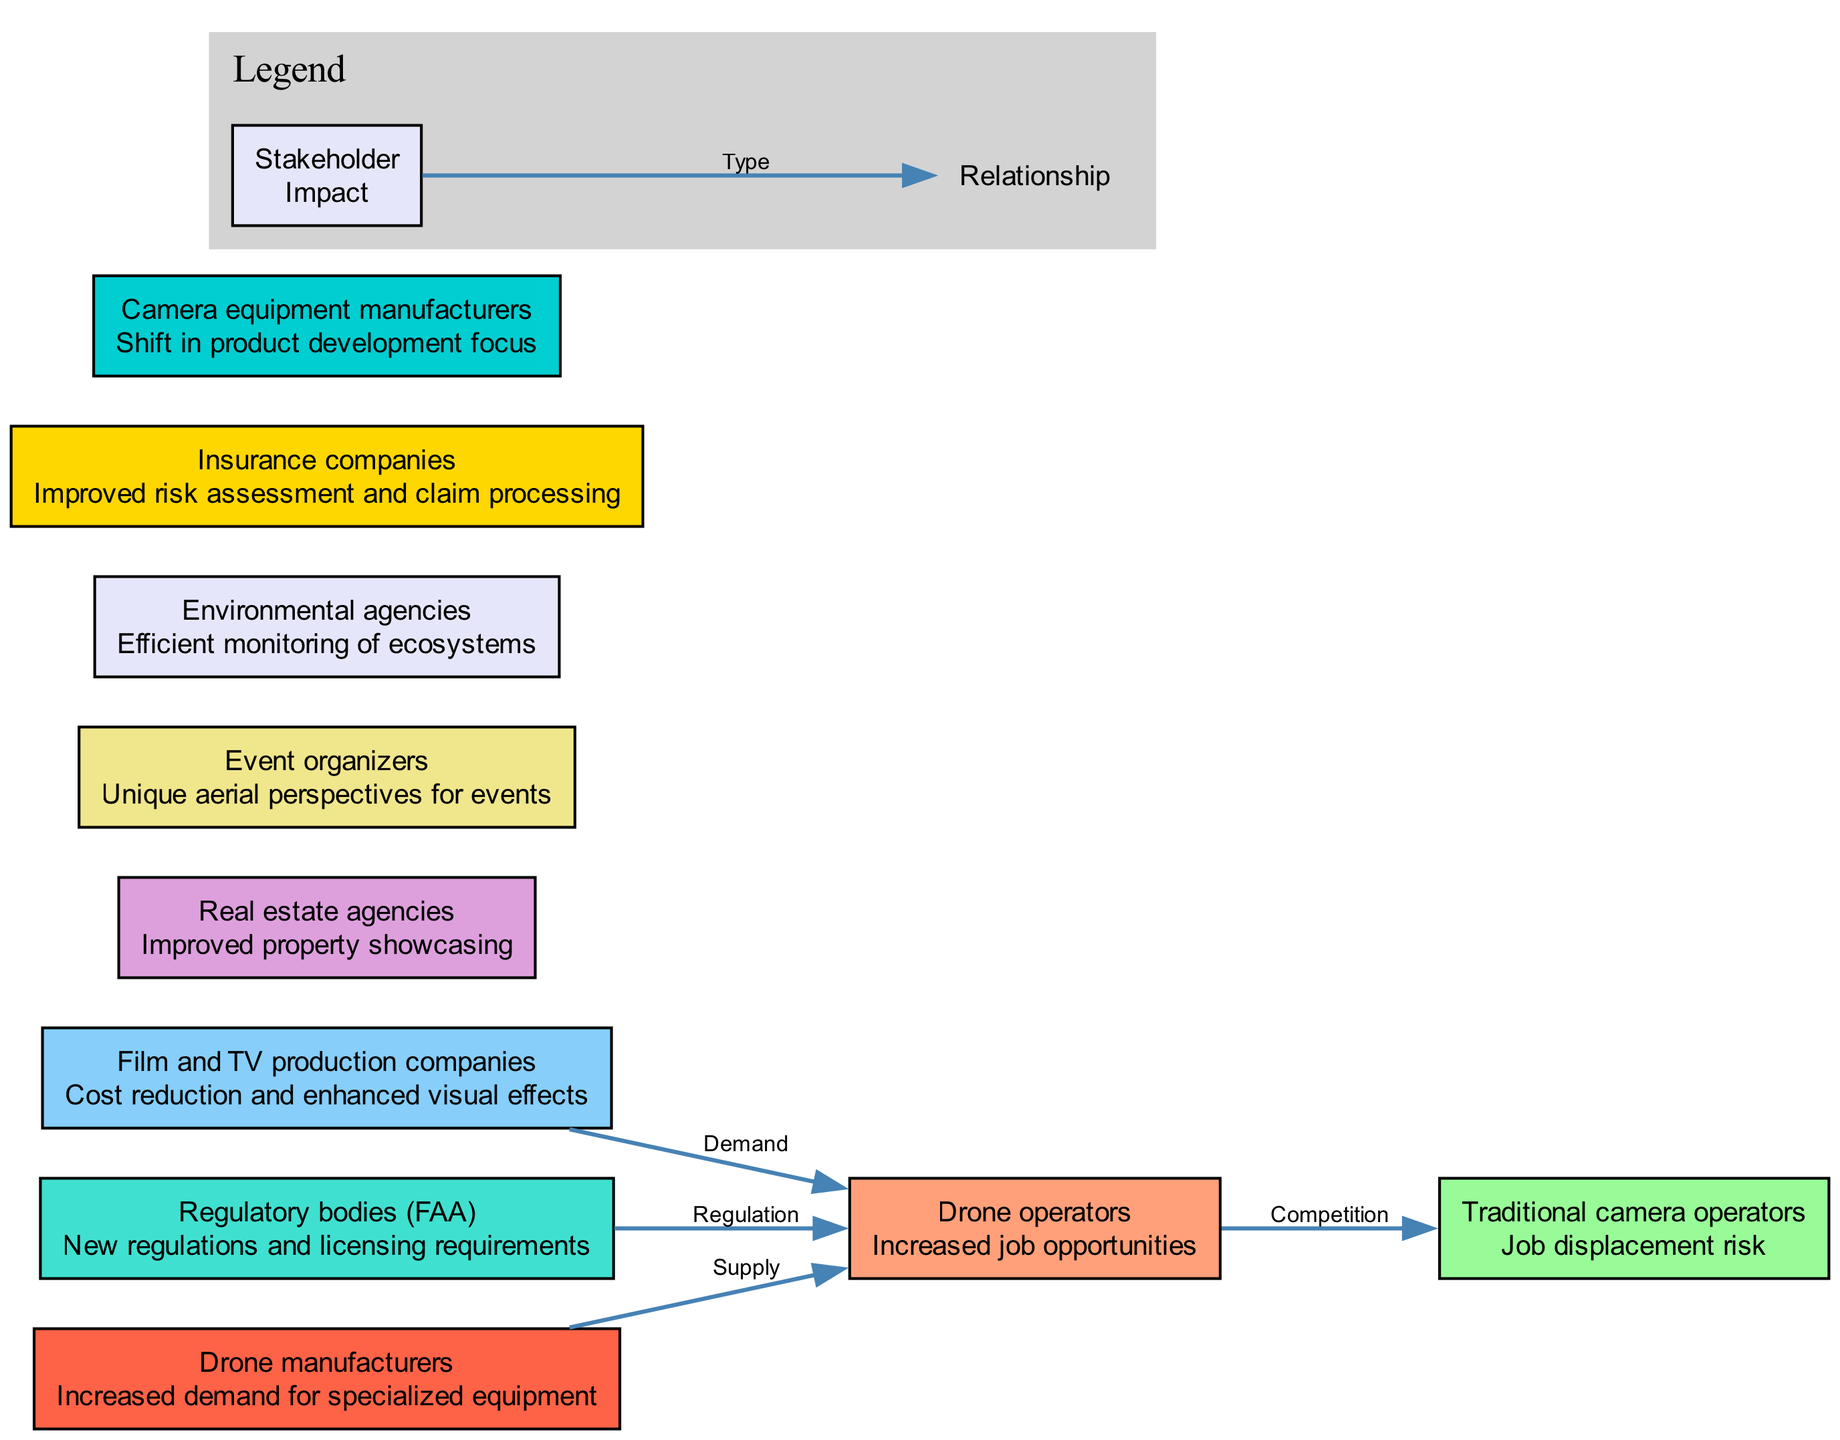What is the impact on drone operators? The diagram shows that the impact on drone operators is "Increased job opportunities," which is directly stated under their node.
Answer: Increased job opportunities How many stakeholders are represented in the diagram? By counting the nodes labeled with stakeholders in the diagram, there are a total of ten stakeholders represented.
Answer: 10 What type of relationship exists between drone operators and traditional camera operators? The diagram specifies that the relationship between drone operators and traditional camera operators is categorized as "Competition," which is indicated on the connecting edge.
Answer: Competition Which stakeholder has an impact related to ecosystem monitoring? The diagram indicates that the "Environmental agencies" stakeholder has the impact of "Efficient monitoring of ecosystems," which can be found in their designated node.
Answer: Environmental agencies What is the relationship type between regulatory bodies and drone operators? According to the diagram, the type of relationship between regulatory bodies (FAA) and drone operators is labeled as "Regulation," which is shown on the edge connecting these two nodes.
Answer: Regulation Which stakeholder is at risk of job displacement? The diagram explicitly states that "Traditional camera operators" are at risk of job displacement, as noted under their impact section in the diagram.
Answer: Traditional camera operators How does the demand for drone operators relate to film and TV production companies? The diagram shows that the relationship type is "Demand," indicating that film and TV production companies drive demand for services provided by drone operators.
Answer: Demand What is the impact on camera equipment manufacturers? The impact on camera equipment manufacturers is "Shift in product development focus," which can be seen in their node within the diagram.
Answer: Shift in product development focus 